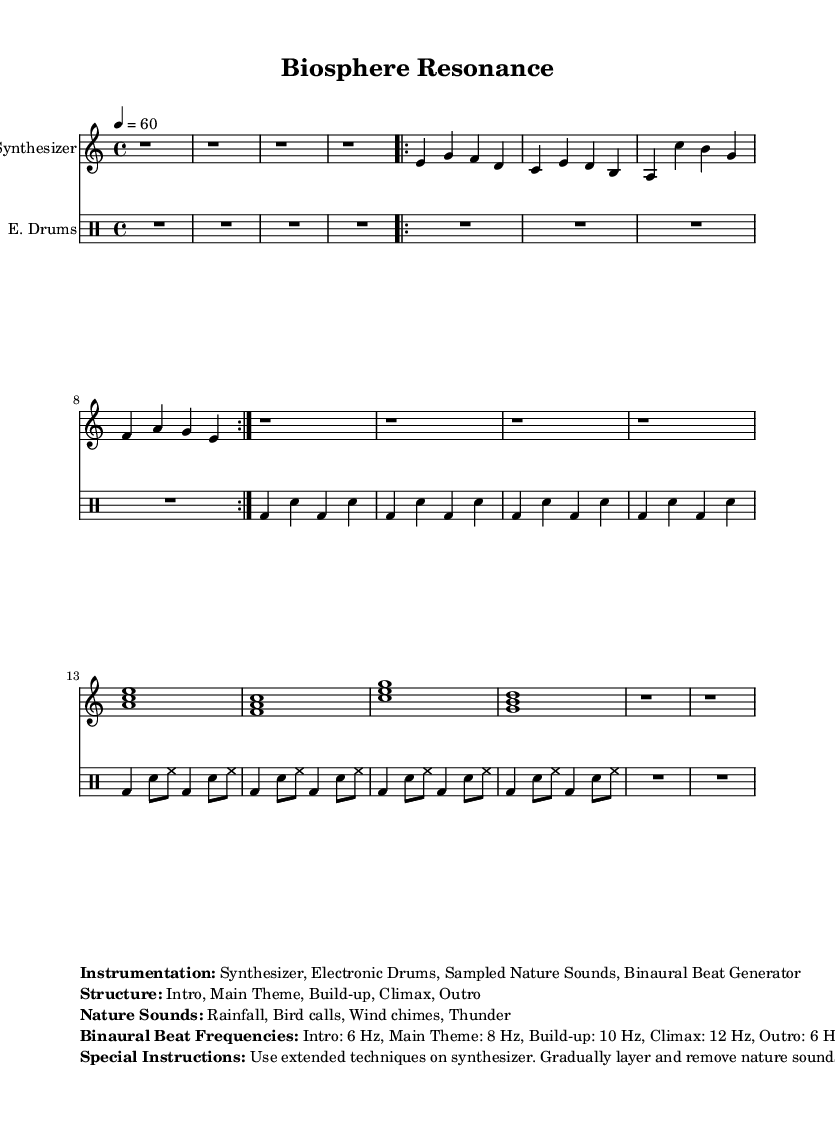What is the time signature of this music? The time signature is indicated at the beginning of the score, where it shows 4/4, meaning there are four beats per measure.
Answer: 4/4 What is the tempo marking in this piece? The tempo marking, found in the initial section of the score, states "4 = 60," indicating a tempo of 60 beats per minute.
Answer: 60 How many sections are in the structure of this composition? By examining the labeled structure in the markup, it shows five distinct sections: Intro, Main Theme, Build-up, Climax, and Outro.
Answer: 5 What binaural beat frequency is used during the Climax section? The markup specifies the binaural beat frequencies for each section, which indicate that the Climax section is set to 12 Hz.
Answer: 12 Hz What nature sounds are included in this piece? The markup section lists the nature sounds used, stating that it includes rainfall, bird calls, wind chimes, and thunder.
Answer: Rainfall, Bird calls, Wind chimes, Thunder Why is extended technique suggested for the synthesizer? The special instructions mention using extended techniques, which involves unconventional playing methods to enhance the sound palette, especially in an experimental ambient context.
Answer: Unconventional sounds What role does the electronic drums part play in the structure of the music? The drums part follows a similar structure, supporting the overall rhythm and building intensity through playing styles during the sections like the Build-up and Climax.
Answer: Rhythm support 